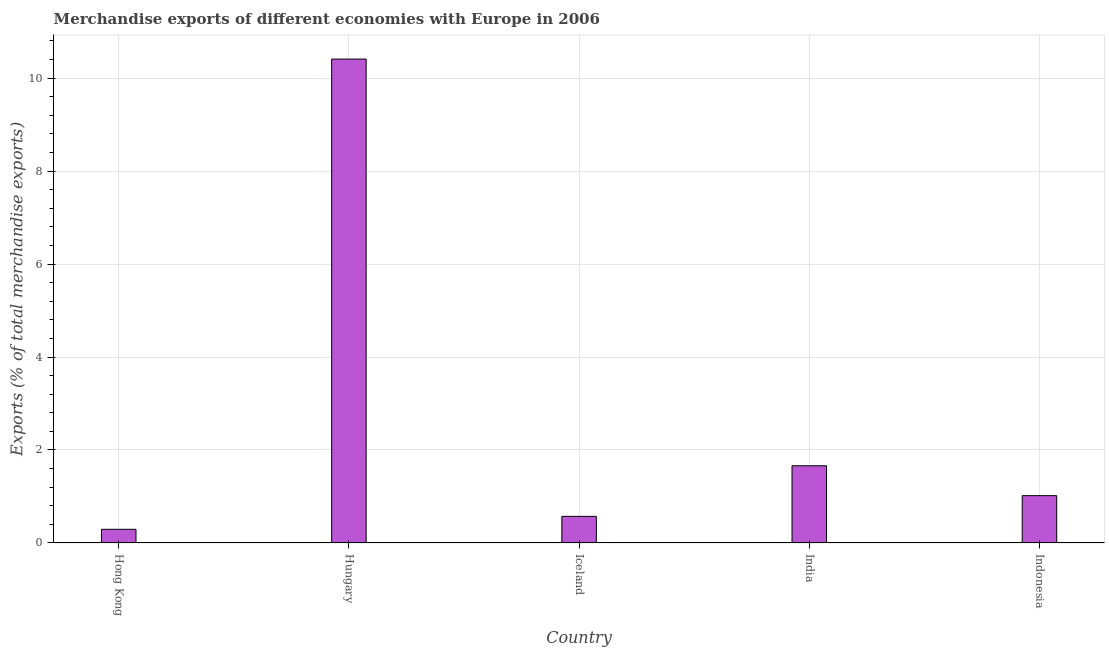What is the title of the graph?
Ensure brevity in your answer.  Merchandise exports of different economies with Europe in 2006. What is the label or title of the Y-axis?
Make the answer very short. Exports (% of total merchandise exports). What is the merchandise exports in Indonesia?
Give a very brief answer. 1.02. Across all countries, what is the maximum merchandise exports?
Provide a succinct answer. 10.41. Across all countries, what is the minimum merchandise exports?
Make the answer very short. 0.29. In which country was the merchandise exports maximum?
Keep it short and to the point. Hungary. In which country was the merchandise exports minimum?
Provide a succinct answer. Hong Kong. What is the sum of the merchandise exports?
Keep it short and to the point. 13.95. What is the difference between the merchandise exports in Hong Kong and Iceland?
Make the answer very short. -0.28. What is the average merchandise exports per country?
Ensure brevity in your answer.  2.79. What is the median merchandise exports?
Provide a short and direct response. 1.02. What is the ratio of the merchandise exports in Iceland to that in Indonesia?
Keep it short and to the point. 0.56. Is the difference between the merchandise exports in Hungary and India greater than the difference between any two countries?
Keep it short and to the point. No. What is the difference between the highest and the second highest merchandise exports?
Provide a short and direct response. 8.75. What is the difference between the highest and the lowest merchandise exports?
Offer a terse response. 10.11. How many bars are there?
Make the answer very short. 5. What is the Exports (% of total merchandise exports) in Hong Kong?
Your answer should be compact. 0.29. What is the Exports (% of total merchandise exports) in Hungary?
Provide a succinct answer. 10.41. What is the Exports (% of total merchandise exports) in Iceland?
Give a very brief answer. 0.57. What is the Exports (% of total merchandise exports) of India?
Ensure brevity in your answer.  1.66. What is the Exports (% of total merchandise exports) of Indonesia?
Offer a terse response. 1.02. What is the difference between the Exports (% of total merchandise exports) in Hong Kong and Hungary?
Your answer should be very brief. -10.11. What is the difference between the Exports (% of total merchandise exports) in Hong Kong and Iceland?
Provide a succinct answer. -0.28. What is the difference between the Exports (% of total merchandise exports) in Hong Kong and India?
Your response must be concise. -1.37. What is the difference between the Exports (% of total merchandise exports) in Hong Kong and Indonesia?
Your answer should be compact. -0.72. What is the difference between the Exports (% of total merchandise exports) in Hungary and Iceland?
Provide a succinct answer. 9.84. What is the difference between the Exports (% of total merchandise exports) in Hungary and India?
Your answer should be compact. 8.75. What is the difference between the Exports (% of total merchandise exports) in Hungary and Indonesia?
Offer a very short reply. 9.39. What is the difference between the Exports (% of total merchandise exports) in Iceland and India?
Keep it short and to the point. -1.09. What is the difference between the Exports (% of total merchandise exports) in Iceland and Indonesia?
Provide a short and direct response. -0.45. What is the difference between the Exports (% of total merchandise exports) in India and Indonesia?
Provide a short and direct response. 0.64. What is the ratio of the Exports (% of total merchandise exports) in Hong Kong to that in Hungary?
Provide a short and direct response. 0.03. What is the ratio of the Exports (% of total merchandise exports) in Hong Kong to that in Iceland?
Keep it short and to the point. 0.51. What is the ratio of the Exports (% of total merchandise exports) in Hong Kong to that in India?
Offer a terse response. 0.18. What is the ratio of the Exports (% of total merchandise exports) in Hong Kong to that in Indonesia?
Offer a very short reply. 0.29. What is the ratio of the Exports (% of total merchandise exports) in Hungary to that in Iceland?
Offer a very short reply. 18.18. What is the ratio of the Exports (% of total merchandise exports) in Hungary to that in India?
Your answer should be very brief. 6.27. What is the ratio of the Exports (% of total merchandise exports) in Hungary to that in Indonesia?
Offer a terse response. 10.22. What is the ratio of the Exports (% of total merchandise exports) in Iceland to that in India?
Give a very brief answer. 0.34. What is the ratio of the Exports (% of total merchandise exports) in Iceland to that in Indonesia?
Offer a terse response. 0.56. What is the ratio of the Exports (% of total merchandise exports) in India to that in Indonesia?
Your response must be concise. 1.63. 